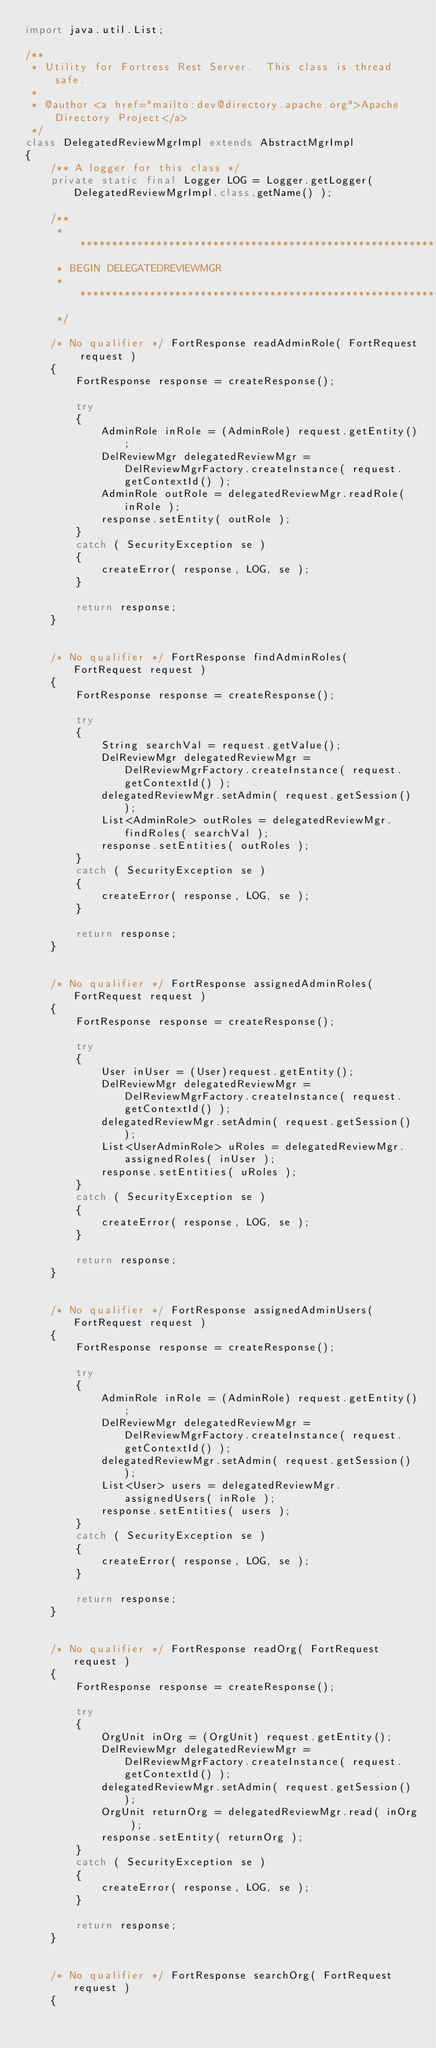Convert code to text. <code><loc_0><loc_0><loc_500><loc_500><_Java_>import java.util.List;

/**
 * Utility for Fortress Rest Server.  This class is thread safe.
 *
 * @author <a href="mailto:dev@directory.apache.org">Apache Directory Project</a>
 */
class DelegatedReviewMgrImpl extends AbstractMgrImpl
{
    /** A logger for this class */
    private static final Logger LOG = Logger.getLogger( DelegatedReviewMgrImpl.class.getName() );

    /**
     * ************************************************************************************************************************************
     * BEGIN DELEGATEDREVIEWMGR
     * **************************************************************************************************************************************
     */

    /* No qualifier */ FortResponse readAdminRole( FortRequest request )
    {
        FortResponse response = createResponse();
        
        try
        {
            AdminRole inRole = (AdminRole) request.getEntity();
            DelReviewMgr delegatedReviewMgr = DelReviewMgrFactory.createInstance( request.getContextId() );
            AdminRole outRole = delegatedReviewMgr.readRole( inRole );
            response.setEntity( outRole );
        }
        catch ( SecurityException se )
        {
            createError( response, LOG, se );
        }
        
        return response;
    }

    
    /* No qualifier */ FortResponse findAdminRoles( FortRequest request )
    {
        FortResponse response = createResponse();
        
        try
        {
            String searchVal = request.getValue();
            DelReviewMgr delegatedReviewMgr = DelReviewMgrFactory.createInstance( request.getContextId() );
            delegatedReviewMgr.setAdmin( request.getSession() );
            List<AdminRole> outRoles = delegatedReviewMgr.findRoles( searchVal );
            response.setEntities( outRoles );
        }
        catch ( SecurityException se )
        {
            createError( response, LOG, se );
        }
        
        return response;
    }

    
    /* No qualifier */ FortResponse assignedAdminRoles( FortRequest request )
    {
        FortResponse response = createResponse();
        
        try
        {
            User inUser = (User)request.getEntity();
            DelReviewMgr delegatedReviewMgr = DelReviewMgrFactory.createInstance( request.getContextId() );
            delegatedReviewMgr.setAdmin( request.getSession() );
            List<UserAdminRole> uRoles = delegatedReviewMgr.assignedRoles( inUser );
            response.setEntities( uRoles );
        }
        catch ( SecurityException se )
        {
            createError( response, LOG, se );
        }
        
        return response;
    }

    
    /* No qualifier */ FortResponse assignedAdminUsers( FortRequest request )
    {
        FortResponse response = createResponse();
        
        try
        {
            AdminRole inRole = (AdminRole) request.getEntity();
            DelReviewMgr delegatedReviewMgr = DelReviewMgrFactory.createInstance( request.getContextId() );
            delegatedReviewMgr.setAdmin( request.getSession() );
            List<User> users = delegatedReviewMgr.assignedUsers( inRole );
            response.setEntities( users );
        }
        catch ( SecurityException se )
        {
            createError( response, LOG, se );
        }
        
        return response;
    }

    
    /* No qualifier */ FortResponse readOrg( FortRequest request )
    {
        FortResponse response = createResponse();
        
        try
        {
            OrgUnit inOrg = (OrgUnit) request.getEntity();
            DelReviewMgr delegatedReviewMgr = DelReviewMgrFactory.createInstance( request.getContextId() );
            delegatedReviewMgr.setAdmin( request.getSession() );
            OrgUnit returnOrg = delegatedReviewMgr.read( inOrg );
            response.setEntity( returnOrg );
        }
        catch ( SecurityException se )
        {
            createError( response, LOG, se );
        }
        
        return response;
    }

    
    /* No qualifier */ FortResponse searchOrg( FortRequest request )
    {</code> 